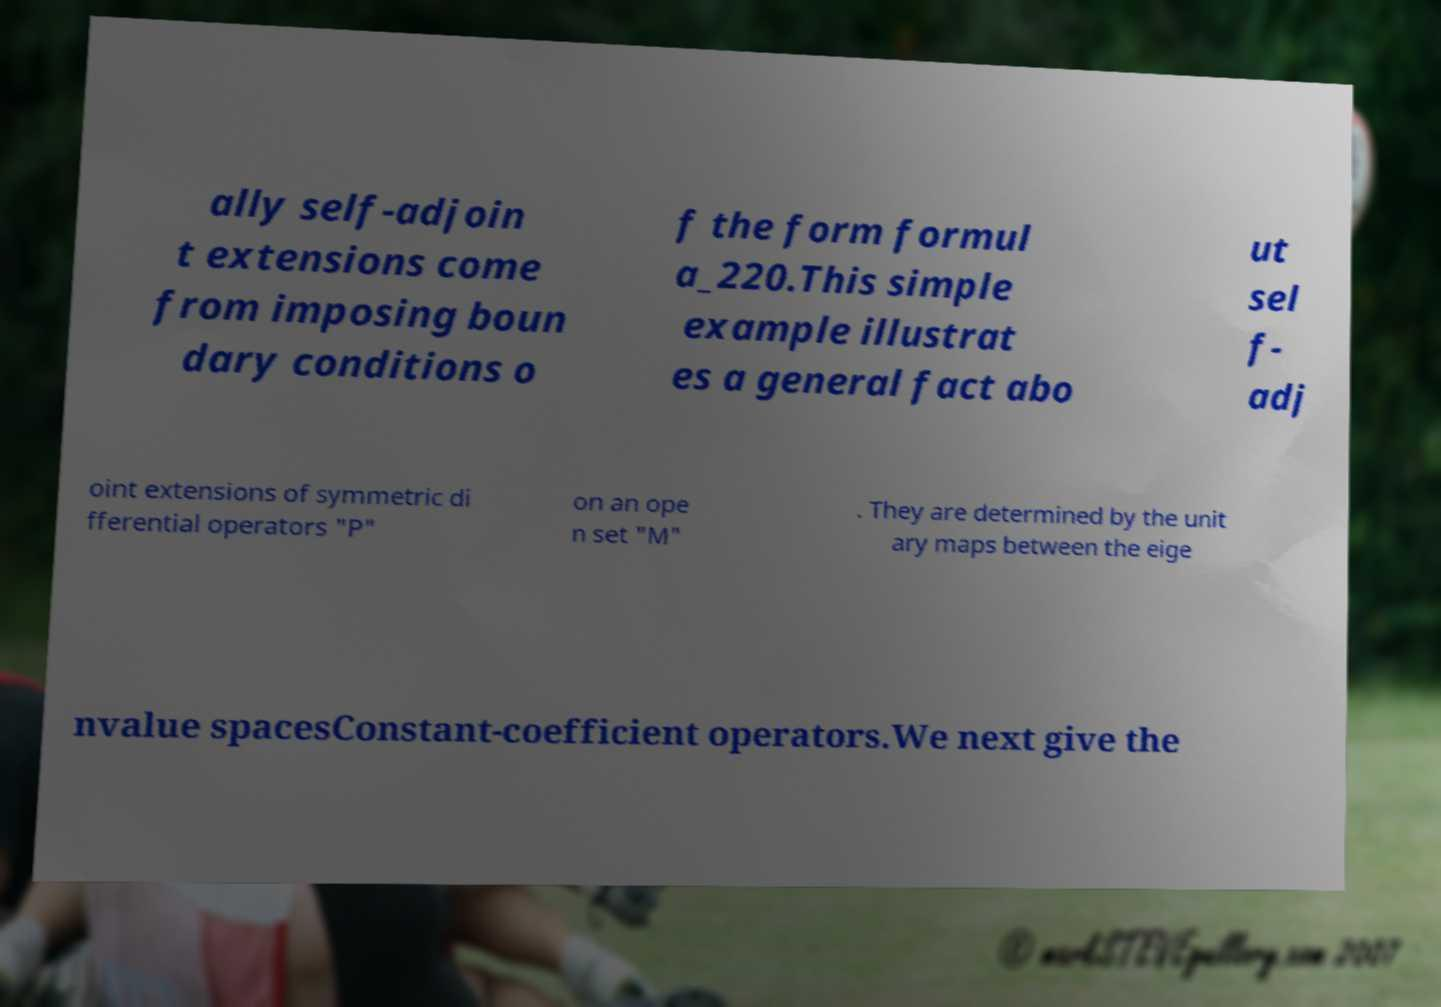Can you accurately transcribe the text from the provided image for me? ally self-adjoin t extensions come from imposing boun dary conditions o f the form formul a_220.This simple example illustrat es a general fact abo ut sel f- adj oint extensions of symmetric di fferential operators "P" on an ope n set "M" . They are determined by the unit ary maps between the eige nvalue spacesConstant-coefficient operators.We next give the 